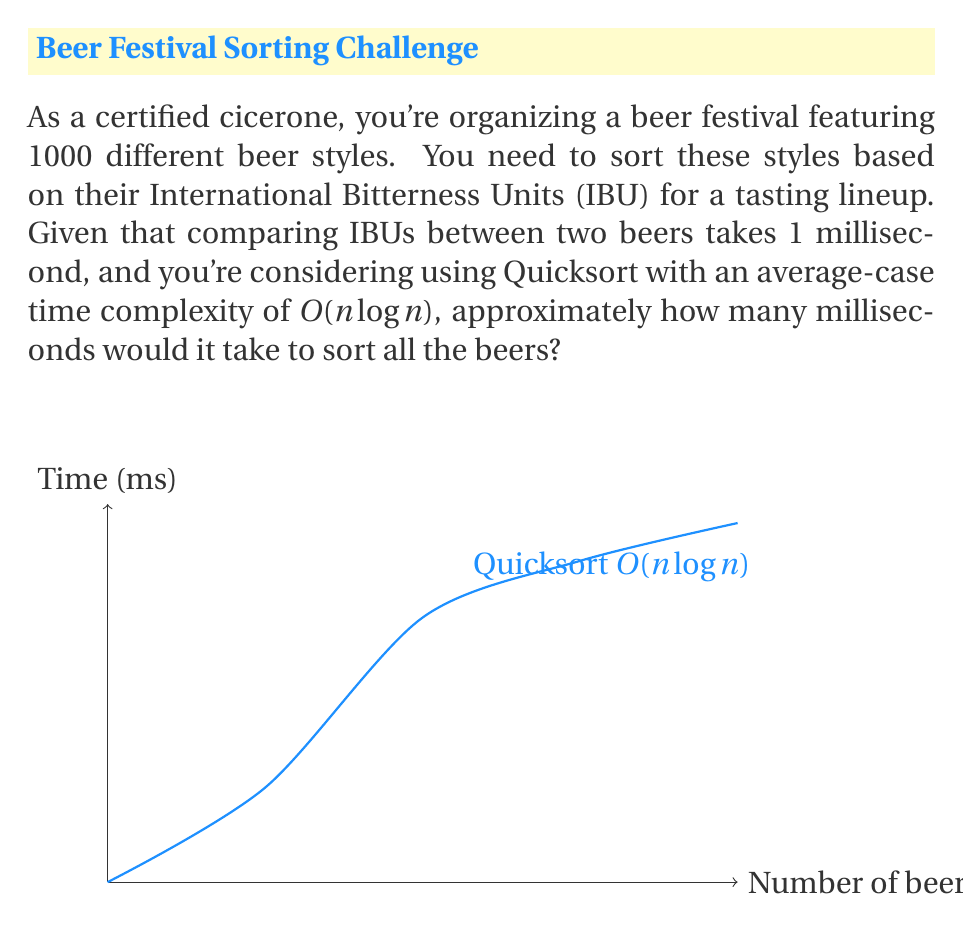Can you answer this question? To solve this problem, we'll follow these steps:

1) The time complexity of Quicksort is $O(n \log n)$, where $n$ is the number of elements to be sorted.

2) In this case, $n = 1000$ (number of beer styles).

3) The exact number of comparisons in Quicksort is approximately $n \log_2 n$ for the average case.

4) Let's calculate $1000 \log_2 1000$:
   
   $1000 \log_2 1000 = 1000 * 9.966 \approx 9966$

5) Each comparison takes 1 millisecond, so we multiply the number of comparisons by 1:

   $9966 * 1 \text{ ms} \approx 9966 \text{ ms}$

6) Rounding to the nearest whole number, we get 9966 milliseconds.
Answer: 9966 ms 